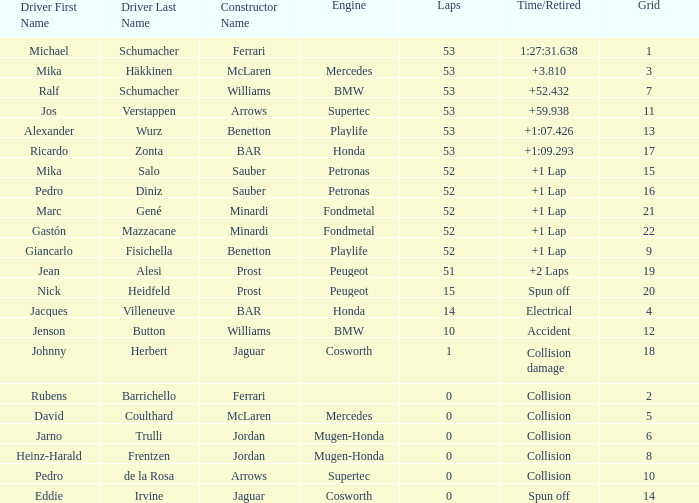What is the median laps for a grid smaller than 17, and a constructor of williams - bmw, operated by jenson button? 10.0. 